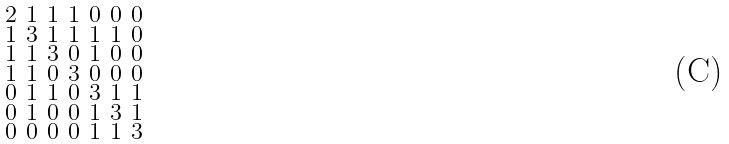Convert formula to latex. <formula><loc_0><loc_0><loc_500><loc_500>\begin{smallmatrix} 2 & 1 & 1 & 1 & 0 & 0 & 0 \\ 1 & 3 & 1 & 1 & 1 & 1 & 0 \\ 1 & 1 & 3 & 0 & 1 & 0 & 0 \\ 1 & 1 & 0 & 3 & 0 & 0 & 0 \\ 0 & 1 & 1 & 0 & 3 & 1 & 1 \\ 0 & 1 & 0 & 0 & 1 & 3 & 1 \\ 0 & 0 & 0 & 0 & 1 & 1 & 3 \end{smallmatrix}</formula> 